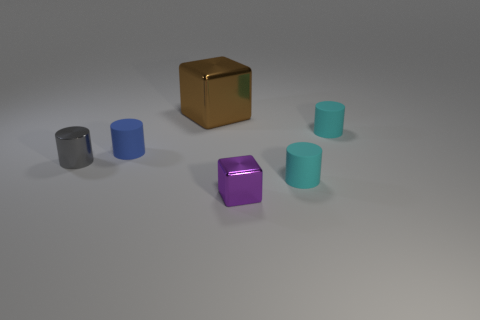Can you describe the different textures and colors visible in the image? Certainly! In the image, we see objects with various textures and colors. There is a brown metal cube with a reflective surface, a shiny purple block, and several cylinders that seem to have a matte texture. The cylinders come in different shades, such as a darker blue and a light teal, which contrasts nicely against the neutral background. 